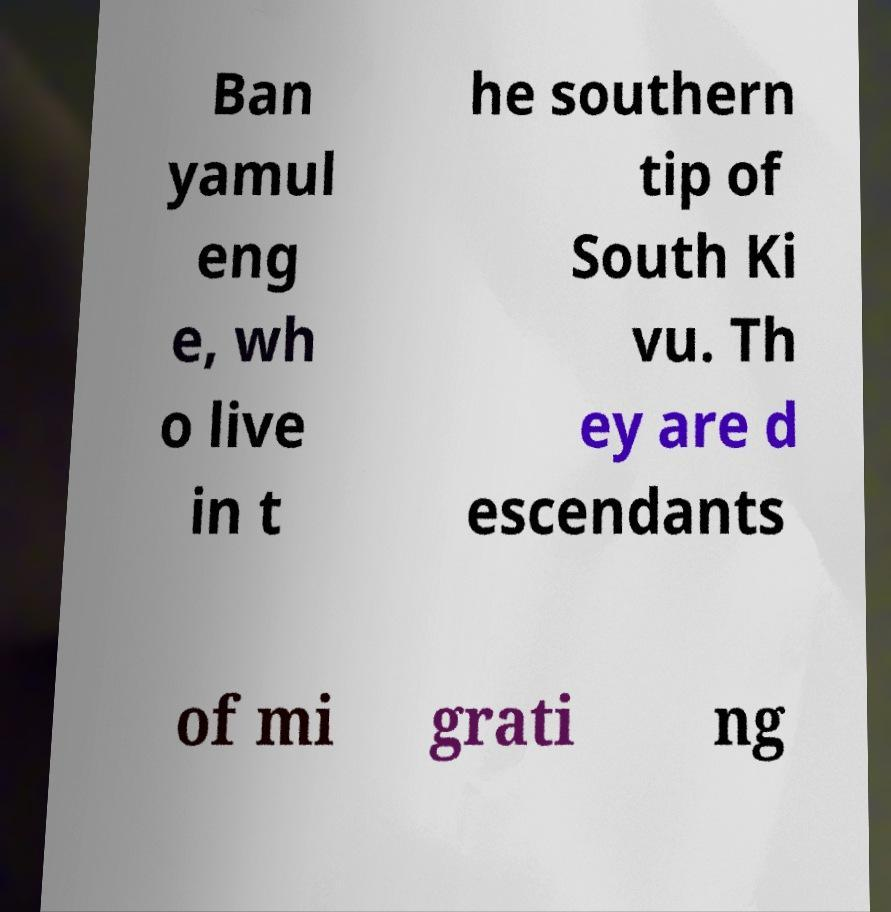I need the written content from this picture converted into text. Can you do that? Ban yamul eng e, wh o live in t he southern tip of South Ki vu. Th ey are d escendants of mi grati ng 